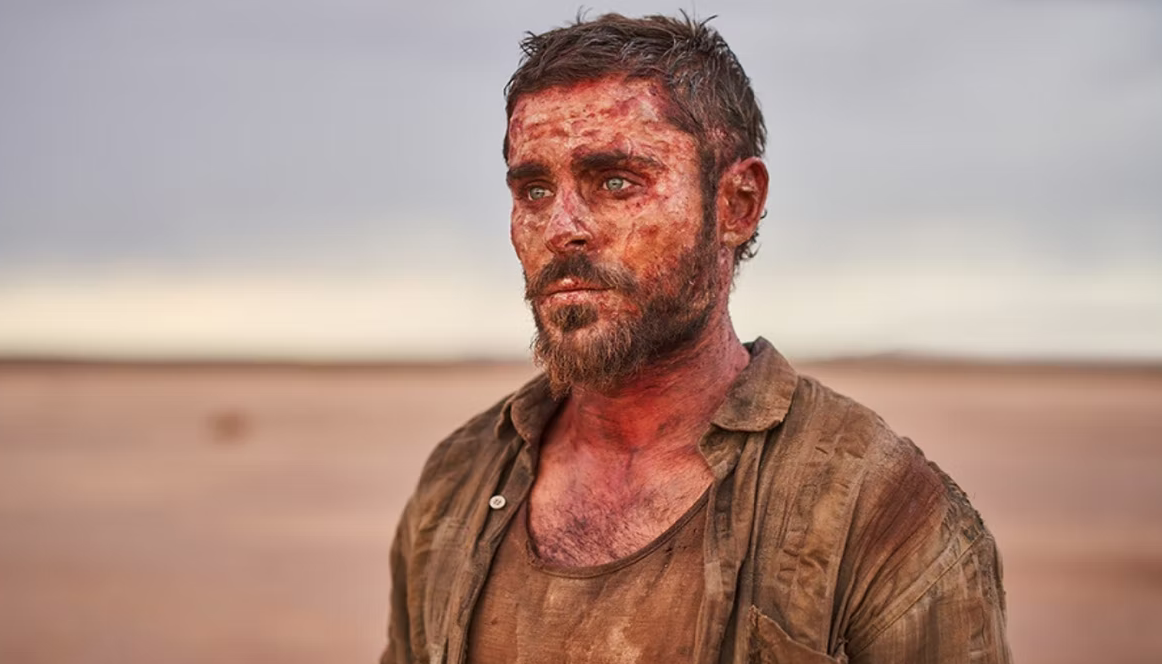Describe a detailed scenario explaining his situation. He was an avid adventure enthusiast, always seeking out the most remote and challenging destinations. This time, he decided to take on the vast desert, planning a route that no one had dared before. He meticulously prepared for the trip, but nature didn't follow his plans. A sudden sandstorm hit, disorienting him and burying his supplies. He wandered for days, trying to find any landmark that looked familiar. The harsh sun burned his skin, and every step became increasingly grueling. His food and water ran out quickly, and he had to fight off wild animals during the nights. His only motivation was the thought of reaching safety and telling the tale of survival. Yet, the isolation took its toll, and now he stands, a testament to human endurance, hoping for a miracle. 